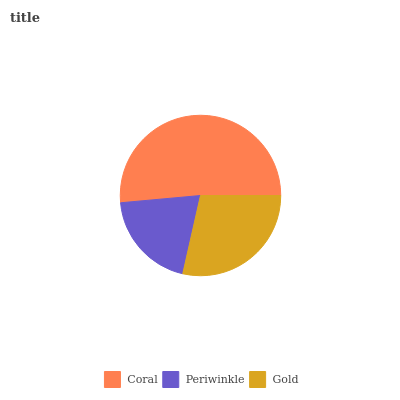Is Periwinkle the minimum?
Answer yes or no. Yes. Is Coral the maximum?
Answer yes or no. Yes. Is Gold the minimum?
Answer yes or no. No. Is Gold the maximum?
Answer yes or no. No. Is Gold greater than Periwinkle?
Answer yes or no. Yes. Is Periwinkle less than Gold?
Answer yes or no. Yes. Is Periwinkle greater than Gold?
Answer yes or no. No. Is Gold less than Periwinkle?
Answer yes or no. No. Is Gold the high median?
Answer yes or no. Yes. Is Gold the low median?
Answer yes or no. Yes. Is Coral the high median?
Answer yes or no. No. Is Periwinkle the low median?
Answer yes or no. No. 